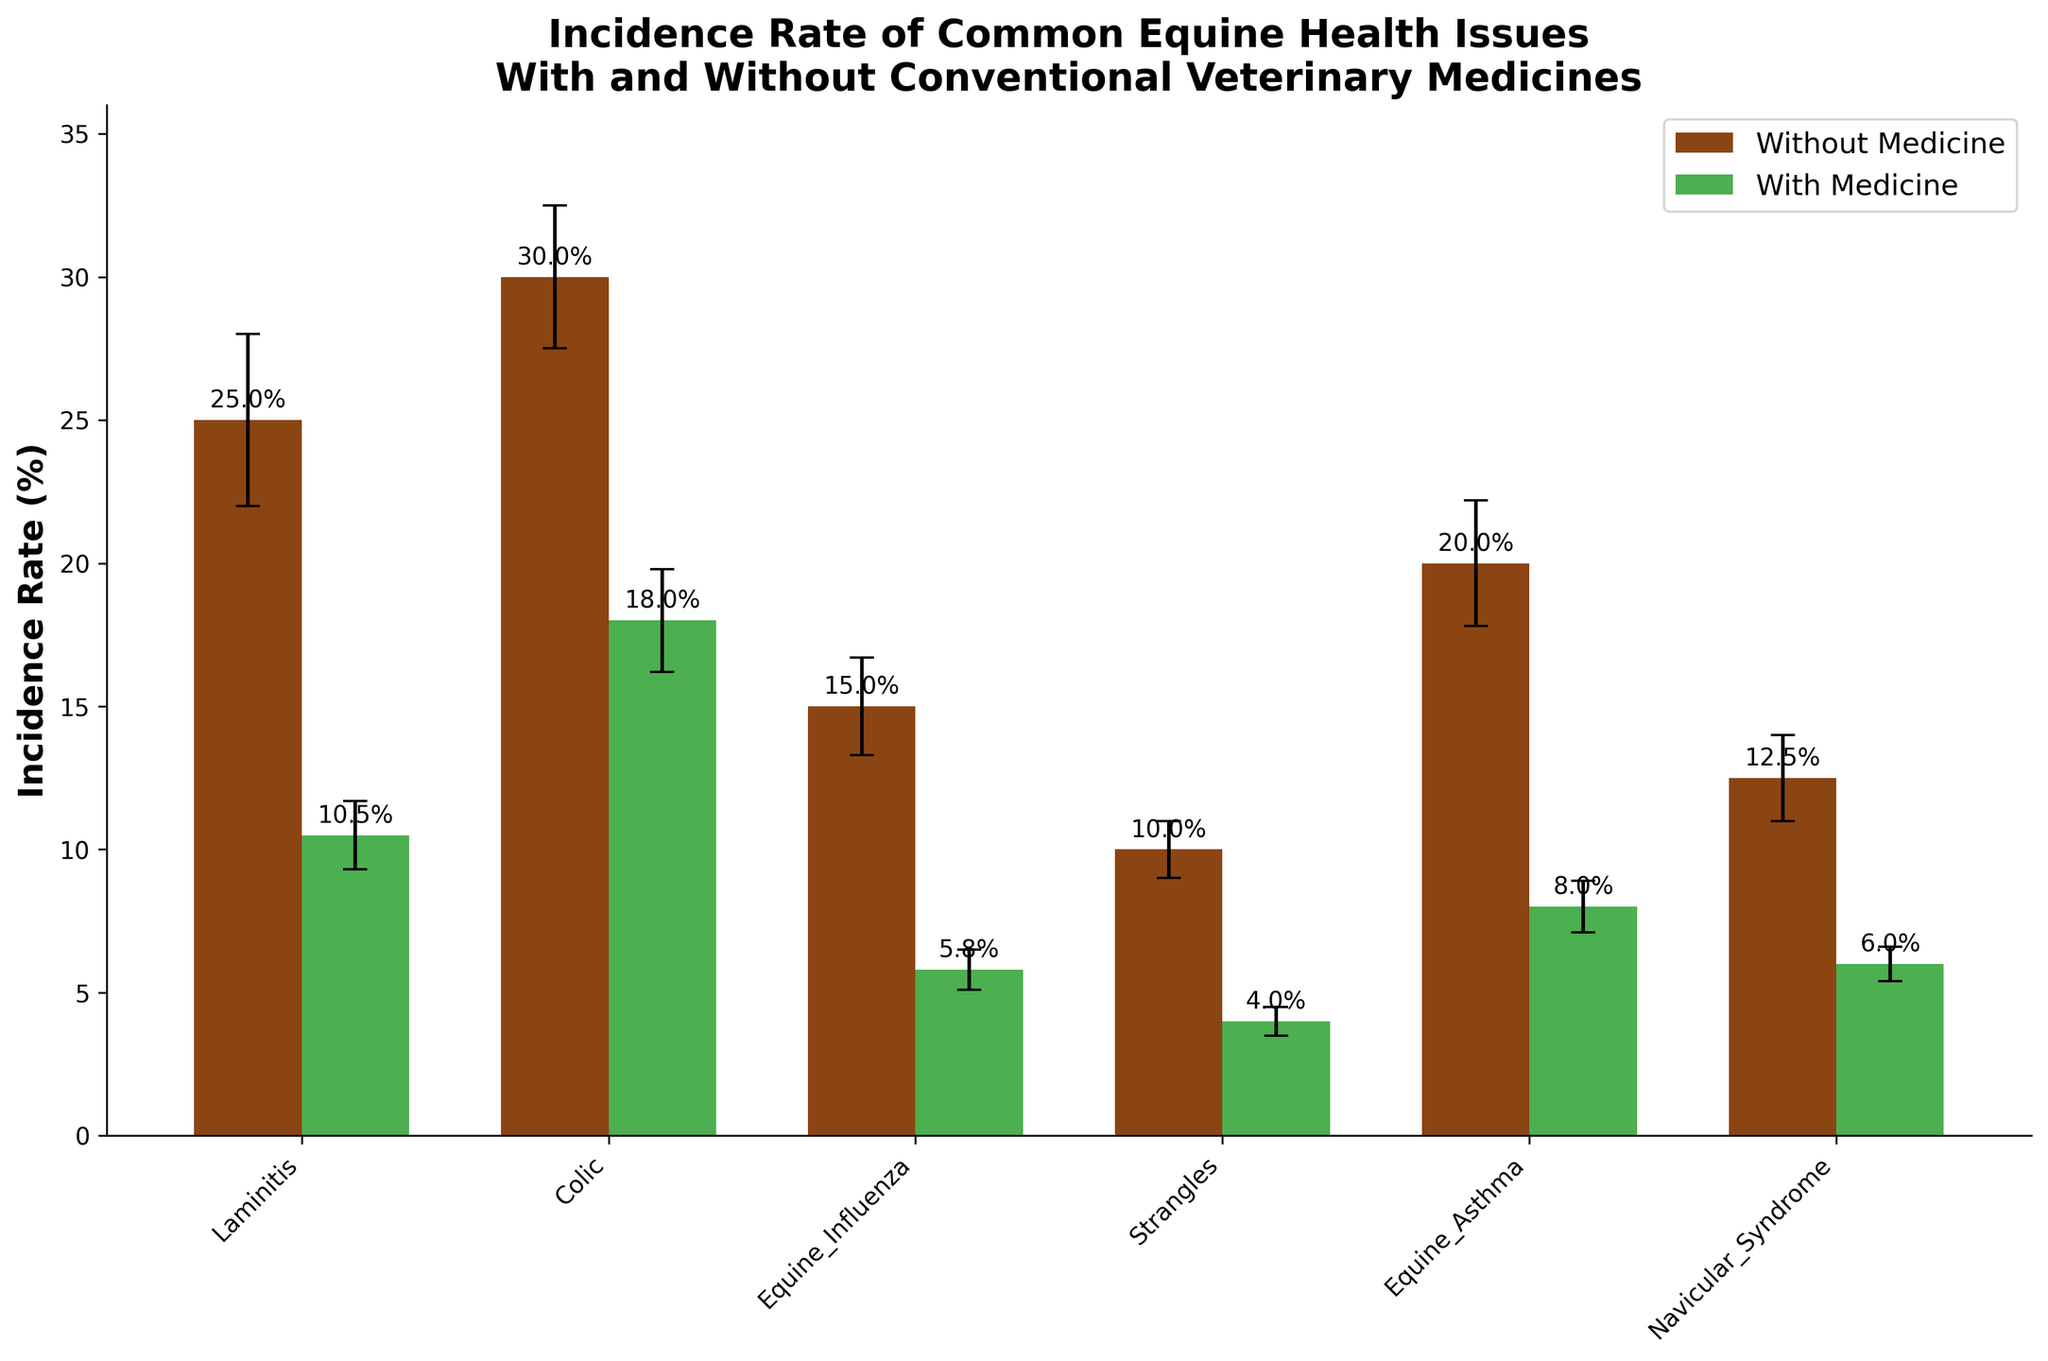What is the title of the figure? The title is located at the top of the plot and provides a summary of what the figure is about. It reads 'Incidence Rate of Common Equine Health Issues With and Without Conventional Veterinary Medicines'.
Answer: Incidence Rate of Common Equine Health Issues With and Without Conventional Veterinary Medicines What does the y-axis represent? The y-axis label indicates the type of measurement being plotted. It reads 'Incidence Rate (%)'.
Answer: Incidence Rate (%) Which health issue has the highest incidence rate without medicine? The health issue with the tallest bar in the 'Without Medicine' category has the highest incidence rate. This is 'Colic' with an incidence rate of 30.0%.
Answer: Colic What is the incidence rate of Laminitis with medicine, including its error bar? The height of the bar for Laminitis in the 'With Medicine' category shows the incidence rate, which is 10.5%. The error bar for this value extends ±1.2%.
Answer: 10.5% ± 1.2% By how much does the incidence rate of Colic reduce when using conventional veterinary medicines? The incidence rate for Colic without medicine is 30.0%, and with medicine, it is 18.0%. The reduction is calculated by subtracting the incidence with medicine from the incidence without medicine: 30.0% - 18.0% = 12.0%.
Answer: 12.0% Which health issue shows the smallest difference in incidence rate between without and with medicine? By comparing the differences between the 'Without Medicine' and 'With Medicine' bars for each health issue, 'Navicular Syndrome' has the smallest difference, going from 12.5% to 6.0%, which is a difference of 6.5%.
Answer: Navicular Syndrome What is the average incidence rate of all health issues with medicine, including its error? The average is calculated by summing the incidence rates with medicine and dividing by the number of health issues. Summing the rates: 10.5 + 18.0 + 5.8 + 4.0 + 8.0 + 6.0 = 52.3. There are 6 health issues, so the average incidence rate is 52.3 / 6 = 8.72%. The overall error can be considered by a simple mean of 1.2, 1.8, 0.7, 0.5, 0.9, and 0.6 which is 0.95%.
Answer: 8.72% ± 0.95% Is the incidence rate of Equine Asthma with medicine less than the incidence rate of Laminitis without medicine? The incidence rate of Equine Asthma with medicine is 8.0% and the incidence rate of Laminitis without medicine is 25.0%. Since 8.0% is less than 25.0%, the statement is true.
Answer: Yes Which health issue has the largest error bar with conventional veterinary medicines? By looking at the lengths of the error bars in the 'With Medicine' category, Colic has the largest error bar at 1.8%.
Answer: Colic 